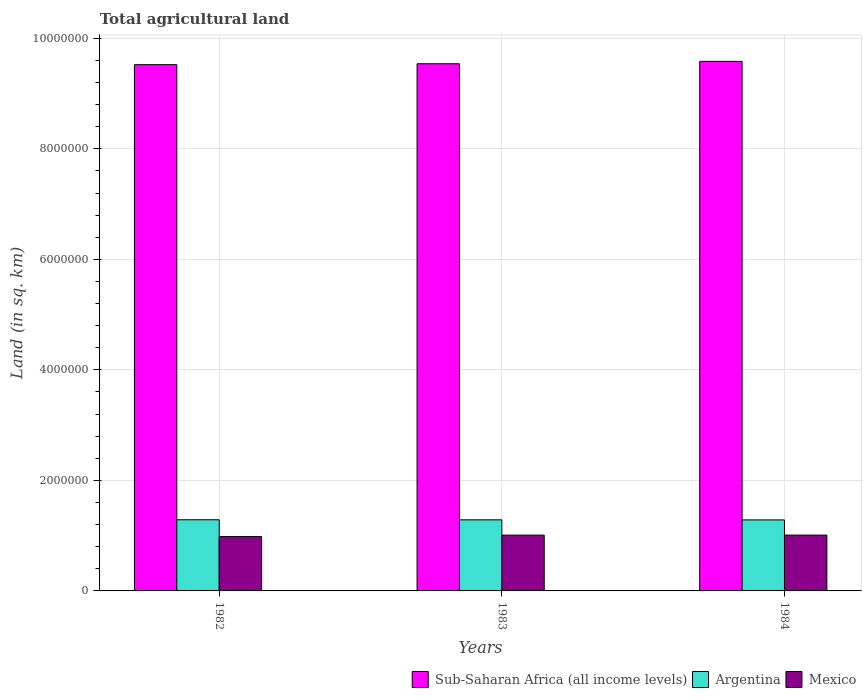Are the number of bars per tick equal to the number of legend labels?
Provide a short and direct response. Yes. Are the number of bars on each tick of the X-axis equal?
Ensure brevity in your answer.  Yes. How many bars are there on the 2nd tick from the left?
Keep it short and to the point. 3. What is the label of the 3rd group of bars from the left?
Provide a short and direct response. 1984. In how many cases, is the number of bars for a given year not equal to the number of legend labels?
Offer a terse response. 0. What is the total agricultural land in Mexico in 1983?
Keep it short and to the point. 1.01e+06. Across all years, what is the maximum total agricultural land in Mexico?
Your answer should be compact. 1.01e+06. Across all years, what is the minimum total agricultural land in Argentina?
Provide a succinct answer. 1.29e+06. What is the total total agricultural land in Mexico in the graph?
Make the answer very short. 3.00e+06. What is the difference between the total agricultural land in Argentina in 1982 and that in 1984?
Provide a short and direct response. 2520. What is the difference between the total agricultural land in Sub-Saharan Africa (all income levels) in 1982 and the total agricultural land in Argentina in 1983?
Your answer should be compact. 8.24e+06. What is the average total agricultural land in Argentina per year?
Provide a succinct answer. 1.29e+06. In the year 1984, what is the difference between the total agricultural land in Argentina and total agricultural land in Sub-Saharan Africa (all income levels)?
Give a very brief answer. -8.30e+06. In how many years, is the total agricultural land in Sub-Saharan Africa (all income levels) greater than 400000 sq.km?
Give a very brief answer. 3. What is the ratio of the total agricultural land in Sub-Saharan Africa (all income levels) in 1983 to that in 1984?
Provide a succinct answer. 1. Is the total agricultural land in Mexico in 1983 less than that in 1984?
Ensure brevity in your answer.  Yes. Is the difference between the total agricultural land in Argentina in 1982 and 1984 greater than the difference between the total agricultural land in Sub-Saharan Africa (all income levels) in 1982 and 1984?
Ensure brevity in your answer.  Yes. What is the difference between the highest and the second highest total agricultural land in Mexico?
Ensure brevity in your answer.  105. What is the difference between the highest and the lowest total agricultural land in Sub-Saharan Africa (all income levels)?
Your answer should be very brief. 5.98e+04. In how many years, is the total agricultural land in Argentina greater than the average total agricultural land in Argentina taken over all years?
Keep it short and to the point. 2. What does the 1st bar from the right in 1982 represents?
Your answer should be very brief. Mexico. Is it the case that in every year, the sum of the total agricultural land in Argentina and total agricultural land in Sub-Saharan Africa (all income levels) is greater than the total agricultural land in Mexico?
Provide a short and direct response. Yes. Are all the bars in the graph horizontal?
Offer a very short reply. No. How many years are there in the graph?
Offer a very short reply. 3. What is the difference between two consecutive major ticks on the Y-axis?
Keep it short and to the point. 2.00e+06. Are the values on the major ticks of Y-axis written in scientific E-notation?
Keep it short and to the point. No. Does the graph contain any zero values?
Your response must be concise. No. How many legend labels are there?
Your answer should be compact. 3. What is the title of the graph?
Ensure brevity in your answer.  Total agricultural land. What is the label or title of the Y-axis?
Offer a very short reply. Land (in sq. km). What is the Land (in sq. km) in Sub-Saharan Africa (all income levels) in 1982?
Offer a very short reply. 9.52e+06. What is the Land (in sq. km) in Argentina in 1982?
Ensure brevity in your answer.  1.29e+06. What is the Land (in sq. km) in Mexico in 1982?
Offer a very short reply. 9.83e+05. What is the Land (in sq. km) of Sub-Saharan Africa (all income levels) in 1983?
Provide a short and direct response. 9.54e+06. What is the Land (in sq. km) in Argentina in 1983?
Offer a very short reply. 1.29e+06. What is the Land (in sq. km) in Mexico in 1983?
Offer a terse response. 1.01e+06. What is the Land (in sq. km) in Sub-Saharan Africa (all income levels) in 1984?
Your answer should be very brief. 9.58e+06. What is the Land (in sq. km) in Argentina in 1984?
Provide a succinct answer. 1.29e+06. What is the Land (in sq. km) in Mexico in 1984?
Your answer should be compact. 1.01e+06. Across all years, what is the maximum Land (in sq. km) in Sub-Saharan Africa (all income levels)?
Your answer should be compact. 9.58e+06. Across all years, what is the maximum Land (in sq. km) in Argentina?
Keep it short and to the point. 1.29e+06. Across all years, what is the maximum Land (in sq. km) of Mexico?
Make the answer very short. 1.01e+06. Across all years, what is the minimum Land (in sq. km) of Sub-Saharan Africa (all income levels)?
Give a very brief answer. 9.52e+06. Across all years, what is the minimum Land (in sq. km) of Argentina?
Your answer should be very brief. 1.29e+06. Across all years, what is the minimum Land (in sq. km) in Mexico?
Offer a terse response. 9.83e+05. What is the total Land (in sq. km) in Sub-Saharan Africa (all income levels) in the graph?
Provide a succinct answer. 2.86e+07. What is the total Land (in sq. km) of Argentina in the graph?
Provide a succinct answer. 3.86e+06. What is the total Land (in sq. km) of Mexico in the graph?
Provide a short and direct response. 3.00e+06. What is the difference between the Land (in sq. km) of Sub-Saharan Africa (all income levels) in 1982 and that in 1983?
Your answer should be very brief. -1.64e+04. What is the difference between the Land (in sq. km) of Argentina in 1982 and that in 1983?
Keep it short and to the point. 1250. What is the difference between the Land (in sq. km) in Mexico in 1982 and that in 1983?
Make the answer very short. -2.70e+04. What is the difference between the Land (in sq. km) of Sub-Saharan Africa (all income levels) in 1982 and that in 1984?
Offer a terse response. -5.98e+04. What is the difference between the Land (in sq. km) in Argentina in 1982 and that in 1984?
Give a very brief answer. 2520. What is the difference between the Land (in sq. km) of Mexico in 1982 and that in 1984?
Offer a very short reply. -2.72e+04. What is the difference between the Land (in sq. km) in Sub-Saharan Africa (all income levels) in 1983 and that in 1984?
Ensure brevity in your answer.  -4.34e+04. What is the difference between the Land (in sq. km) of Argentina in 1983 and that in 1984?
Provide a succinct answer. 1270. What is the difference between the Land (in sq. km) of Mexico in 1983 and that in 1984?
Your answer should be compact. -105. What is the difference between the Land (in sq. km) in Sub-Saharan Africa (all income levels) in 1982 and the Land (in sq. km) in Argentina in 1983?
Give a very brief answer. 8.24e+06. What is the difference between the Land (in sq. km) of Sub-Saharan Africa (all income levels) in 1982 and the Land (in sq. km) of Mexico in 1983?
Your response must be concise. 8.51e+06. What is the difference between the Land (in sq. km) of Argentina in 1982 and the Land (in sq. km) of Mexico in 1983?
Your answer should be very brief. 2.77e+05. What is the difference between the Land (in sq. km) of Sub-Saharan Africa (all income levels) in 1982 and the Land (in sq. km) of Argentina in 1984?
Your answer should be compact. 8.24e+06. What is the difference between the Land (in sq. km) of Sub-Saharan Africa (all income levels) in 1982 and the Land (in sq. km) of Mexico in 1984?
Your response must be concise. 8.51e+06. What is the difference between the Land (in sq. km) of Argentina in 1982 and the Land (in sq. km) of Mexico in 1984?
Your answer should be compact. 2.77e+05. What is the difference between the Land (in sq. km) in Sub-Saharan Africa (all income levels) in 1983 and the Land (in sq. km) in Argentina in 1984?
Offer a very short reply. 8.25e+06. What is the difference between the Land (in sq. km) of Sub-Saharan Africa (all income levels) in 1983 and the Land (in sq. km) of Mexico in 1984?
Your answer should be compact. 8.53e+06. What is the difference between the Land (in sq. km) in Argentina in 1983 and the Land (in sq. km) in Mexico in 1984?
Ensure brevity in your answer.  2.76e+05. What is the average Land (in sq. km) in Sub-Saharan Africa (all income levels) per year?
Provide a succinct answer. 9.55e+06. What is the average Land (in sq. km) in Argentina per year?
Keep it short and to the point. 1.29e+06. What is the average Land (in sq. km) of Mexico per year?
Provide a short and direct response. 1.00e+06. In the year 1982, what is the difference between the Land (in sq. km) of Sub-Saharan Africa (all income levels) and Land (in sq. km) of Argentina?
Provide a succinct answer. 8.24e+06. In the year 1982, what is the difference between the Land (in sq. km) in Sub-Saharan Africa (all income levels) and Land (in sq. km) in Mexico?
Ensure brevity in your answer.  8.54e+06. In the year 1982, what is the difference between the Land (in sq. km) of Argentina and Land (in sq. km) of Mexico?
Provide a short and direct response. 3.05e+05. In the year 1983, what is the difference between the Land (in sq. km) in Sub-Saharan Africa (all income levels) and Land (in sq. km) in Argentina?
Offer a very short reply. 8.25e+06. In the year 1983, what is the difference between the Land (in sq. km) of Sub-Saharan Africa (all income levels) and Land (in sq. km) of Mexico?
Ensure brevity in your answer.  8.53e+06. In the year 1983, what is the difference between the Land (in sq. km) of Argentina and Land (in sq. km) of Mexico?
Your response must be concise. 2.76e+05. In the year 1984, what is the difference between the Land (in sq. km) in Sub-Saharan Africa (all income levels) and Land (in sq. km) in Argentina?
Make the answer very short. 8.30e+06. In the year 1984, what is the difference between the Land (in sq. km) of Sub-Saharan Africa (all income levels) and Land (in sq. km) of Mexico?
Your answer should be very brief. 8.57e+06. In the year 1984, what is the difference between the Land (in sq. km) in Argentina and Land (in sq. km) in Mexico?
Give a very brief answer. 2.75e+05. What is the ratio of the Land (in sq. km) in Sub-Saharan Africa (all income levels) in 1982 to that in 1983?
Offer a terse response. 1. What is the ratio of the Land (in sq. km) of Argentina in 1982 to that in 1983?
Make the answer very short. 1. What is the ratio of the Land (in sq. km) in Mexico in 1982 to that in 1983?
Ensure brevity in your answer.  0.97. What is the ratio of the Land (in sq. km) of Sub-Saharan Africa (all income levels) in 1982 to that in 1984?
Ensure brevity in your answer.  0.99. What is the ratio of the Land (in sq. km) of Argentina in 1982 to that in 1984?
Offer a terse response. 1. What is the ratio of the Land (in sq. km) in Mexico in 1982 to that in 1984?
Ensure brevity in your answer.  0.97. What is the ratio of the Land (in sq. km) of Sub-Saharan Africa (all income levels) in 1983 to that in 1984?
Offer a terse response. 1. What is the ratio of the Land (in sq. km) of Mexico in 1983 to that in 1984?
Your response must be concise. 1. What is the difference between the highest and the second highest Land (in sq. km) of Sub-Saharan Africa (all income levels)?
Your answer should be very brief. 4.34e+04. What is the difference between the highest and the second highest Land (in sq. km) in Argentina?
Provide a succinct answer. 1250. What is the difference between the highest and the second highest Land (in sq. km) in Mexico?
Keep it short and to the point. 105. What is the difference between the highest and the lowest Land (in sq. km) of Sub-Saharan Africa (all income levels)?
Keep it short and to the point. 5.98e+04. What is the difference between the highest and the lowest Land (in sq. km) in Argentina?
Your response must be concise. 2520. What is the difference between the highest and the lowest Land (in sq. km) in Mexico?
Offer a very short reply. 2.72e+04. 